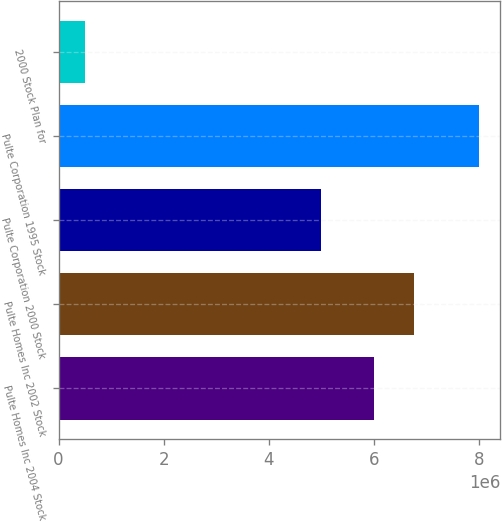Convert chart to OTSL. <chart><loc_0><loc_0><loc_500><loc_500><bar_chart><fcel>Pulte Homes Inc 2004 Stock<fcel>Pulte Homes Inc 2002 Stock<fcel>Pulte Corporation 2000 Stock<fcel>Pulte Corporation 1995 Stock<fcel>2000 Stock Plan for<nl><fcel>6e+06<fcel>6.75e+06<fcel>5e+06<fcel>8e+06<fcel>500000<nl></chart> 